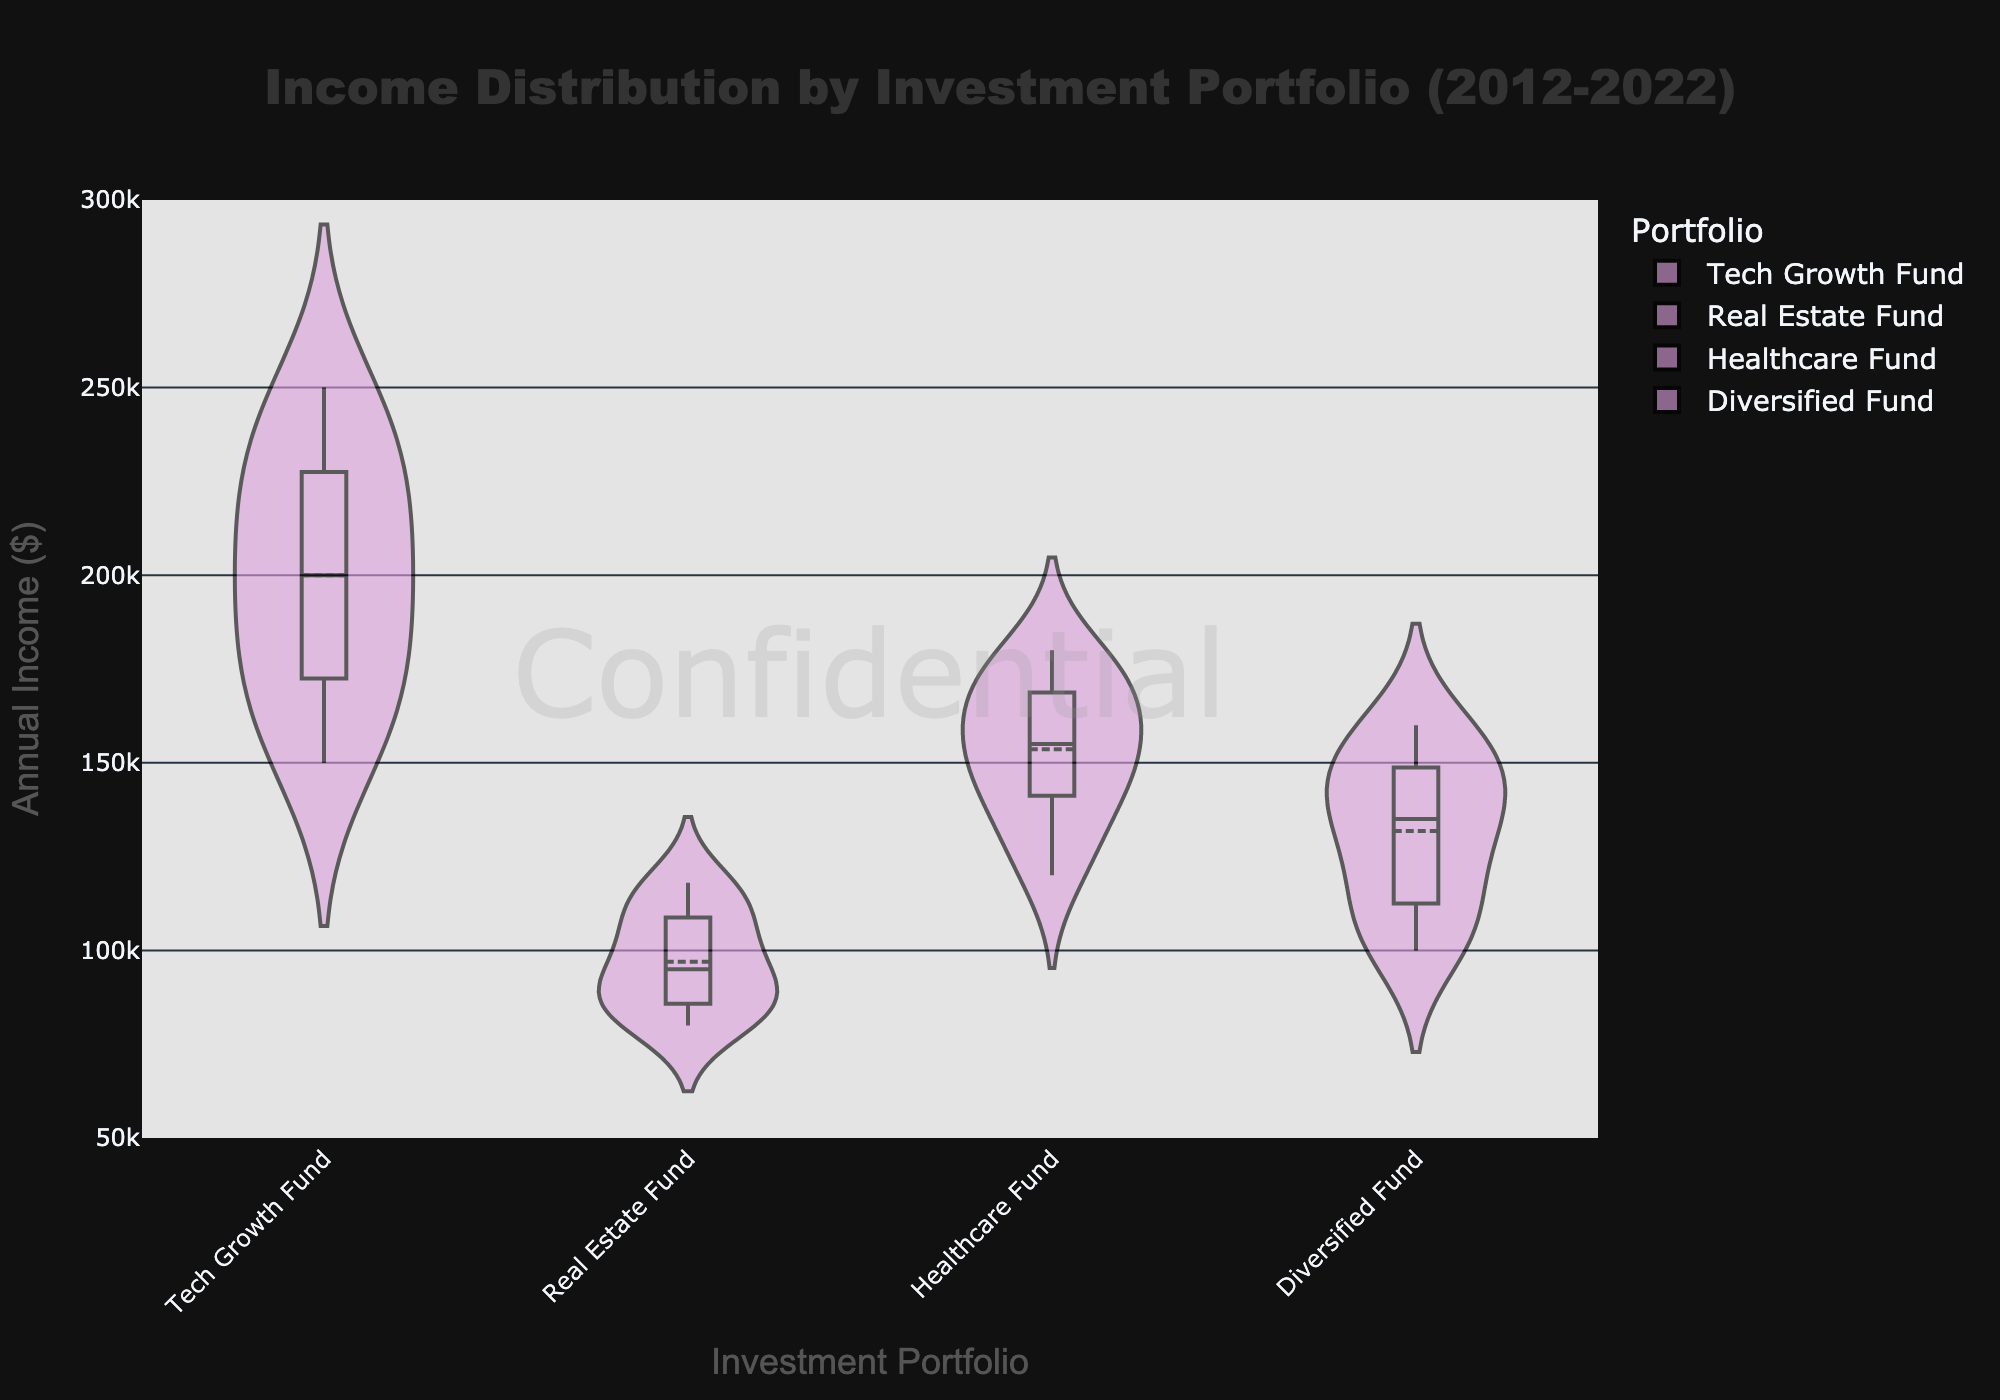Which portfolio shows the highest average annual income? By looking at the mean line visible in each of the violin plots, the Tech Growth Fund exhibits the highest average annual income as indicated by the mean line within the box of the violin plot.
Answer: Tech Growth Fund Which portfolio has the least variability in income over the last decade? The Real Estate Fund has the narrowest spread in its violin plot, indicating the least variability in income distribution over the years.
Answer: Real Estate Fund What is the median annual income for the Healthcare Fund? The box plot overlaid on the Healthcare Fund's violin plot shows the median line, which falls around $155,000.
Answer: $155,000 Which portfolio has the widest range of income? Examining the spread of the violin plots, the Tech Growth Fund's plot shows the widest range, indicating the highest variability in annual income.
Answer: Tech Growth Fund How does the median income of the Diversified Fund compare to the median income of the Real Estate Fund? By observing the median lines in the box plots, the Diversified Fund's median is higher, approximately at $150,000, compared to the Real Estate Fund's median at around $97,000.
Answer: Diversified Fund's median is higher What is the income range for the Tech Growth Fund? The box plot overlaid on the Tech Growth Fund's violin plot shows the range from approximately $150,000 to $250,000.
Answer: $150,000 to $250,000 Is there any portfolio that has a mean line and median line significantly different? The Tech Growth Fund’s mean and median lines appear quite close, indicating symmetry. Similarly, other portfolios show no significant differences between their mean and median lines.
Answer: No Which portfolio has shown the most consistent income growth over the years based on the plot? The smooth and narrow shape of the violin plot for the Real Estate Fund suggests consistent income growth over the past decade.
Answer: Real Estate Fund For which portfolio is the discrepancy between mean and median smallest? By observing the positions of the mean and median lines in the box plots, the discrepancy seems smallest in the Real Estate Fund's plot.
Answer: Real Estate Fund What is the title of the figure? The title of the figure is clearly displayed above the plots and reads "Income Distribution by Investment Portfolio (2012-2022)."
Answer: Income Distribution by Investment Portfolio (2012-2022) 